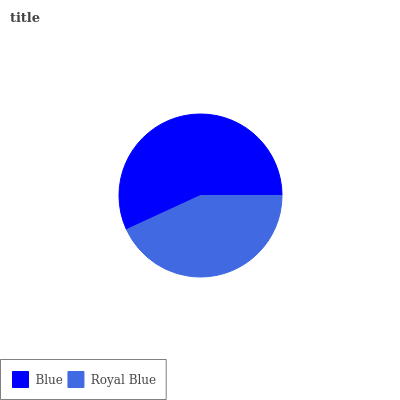Is Royal Blue the minimum?
Answer yes or no. Yes. Is Blue the maximum?
Answer yes or no. Yes. Is Royal Blue the maximum?
Answer yes or no. No. Is Blue greater than Royal Blue?
Answer yes or no. Yes. Is Royal Blue less than Blue?
Answer yes or no. Yes. Is Royal Blue greater than Blue?
Answer yes or no. No. Is Blue less than Royal Blue?
Answer yes or no. No. Is Blue the high median?
Answer yes or no. Yes. Is Royal Blue the low median?
Answer yes or no. Yes. Is Royal Blue the high median?
Answer yes or no. No. Is Blue the low median?
Answer yes or no. No. 